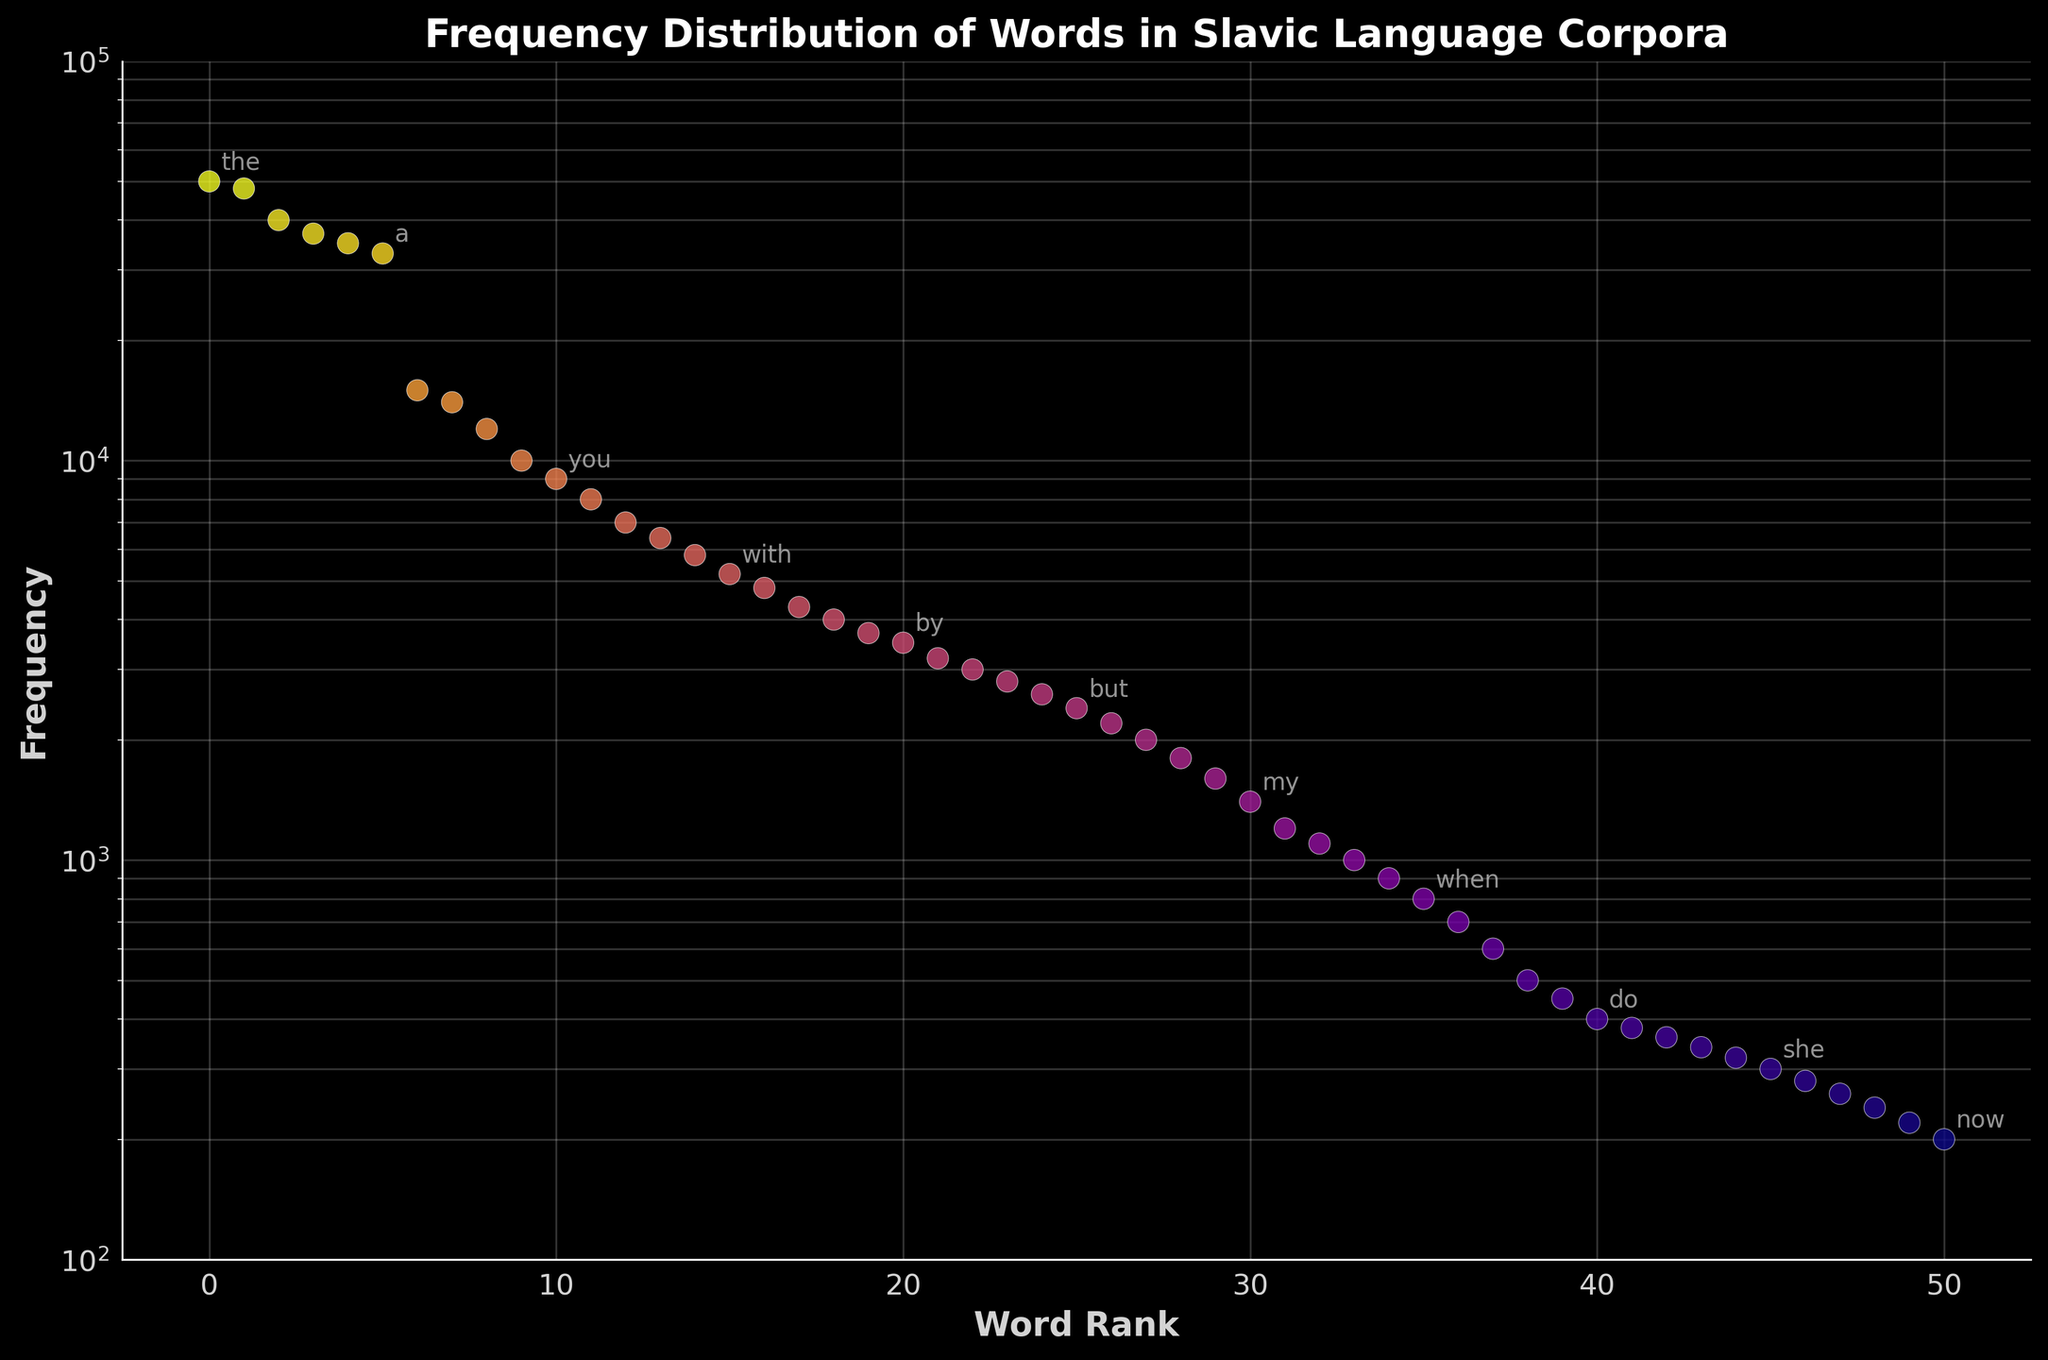What's the title of the figure? The title of the figure is located at the top of the plot; it is displayed in bold white text.
Answer: Frequency Distribution of Words in Slavic Language Corpora What is the frequency of the word 'I'? The frequency distribution plot uses a scatter plot, and 'I' is annotated at its corresponding log-scale frequency on the y-axis and rank on the x-axis.
Answer: 10,000 How many words have a frequency greater than 10,000? By inspecting the plot, we can identify the points with frequencies greater than 10,000 on the y-axis. Count these points.
Answer: 6 Compare the frequency of the words 'my' and 'you'. Which one is higher? Find the frequencies of 'my' and 'you' annotated on the plot and compare them; 'you' should have a higher frequency.
Answer: you What is the range of frequencies shown on the y-axis? The minimum and maximum values on the y-axis represent the range of frequencies.
Answer: 100 to 100,000 What can you infer about the distribution of the words in the corpus? The frequent words are more common and many words have low frequencies, indicating a long tail distribution typically seen in natural language corpora.
Answer: Long tail distribution Which word has the lowest frequency, according to the plot? Identify the lowest point on the y-axis; the word annotated with this frequency is the answer.
Answer: now What is the approximate frequency of the word ranked 10th? Find the 10th word on the x-axis and read its corresponding y-axis value, closely matching it to the annotations.
Answer: 10,000 How does the plot clarify the difference between common and rare words? The plot uses different colors (plasma color map) and annotations to highlight the word frequencies, showing a clear visual contrast between high and low frequencies.
Answer: Differentiates visually Is the word 'then' more or less frequent than 'us'? Locate both words on the plot and compare their y-axis positions. 'Then' is higher than 'us'.
Answer: more frequent 